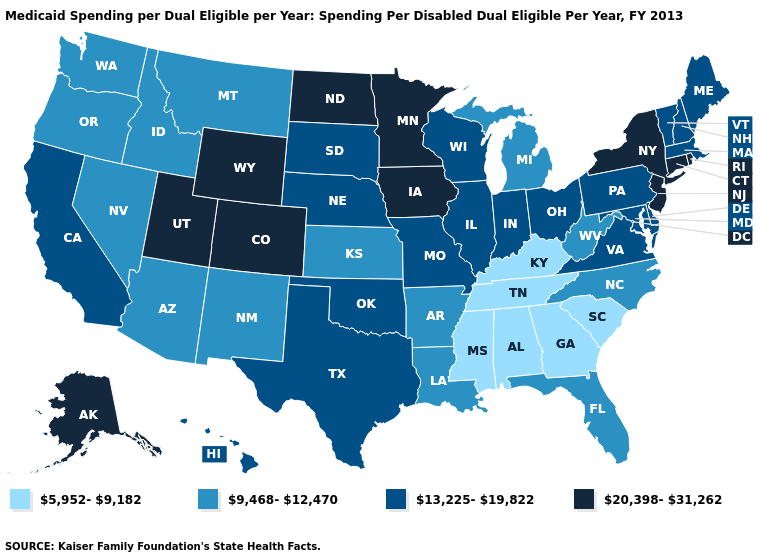What is the lowest value in the USA?
Give a very brief answer. 5,952-9,182. Name the states that have a value in the range 5,952-9,182?
Be succinct. Alabama, Georgia, Kentucky, Mississippi, South Carolina, Tennessee. Name the states that have a value in the range 20,398-31,262?
Short answer required. Alaska, Colorado, Connecticut, Iowa, Minnesota, New Jersey, New York, North Dakota, Rhode Island, Utah, Wyoming. Does Pennsylvania have the highest value in the USA?
Give a very brief answer. No. What is the value of West Virginia?
Concise answer only. 9,468-12,470. What is the lowest value in states that border Delaware?
Short answer required. 13,225-19,822. Name the states that have a value in the range 9,468-12,470?
Be succinct. Arizona, Arkansas, Florida, Idaho, Kansas, Louisiana, Michigan, Montana, Nevada, New Mexico, North Carolina, Oregon, Washington, West Virginia. What is the value of Utah?
Concise answer only. 20,398-31,262. Does the first symbol in the legend represent the smallest category?
Concise answer only. Yes. What is the value of New Hampshire?
Write a very short answer. 13,225-19,822. Does Ohio have a lower value than New Mexico?
Give a very brief answer. No. What is the value of Utah?
Give a very brief answer. 20,398-31,262. What is the lowest value in the West?
Answer briefly. 9,468-12,470. Is the legend a continuous bar?
Be succinct. No. What is the value of Indiana?
Write a very short answer. 13,225-19,822. 